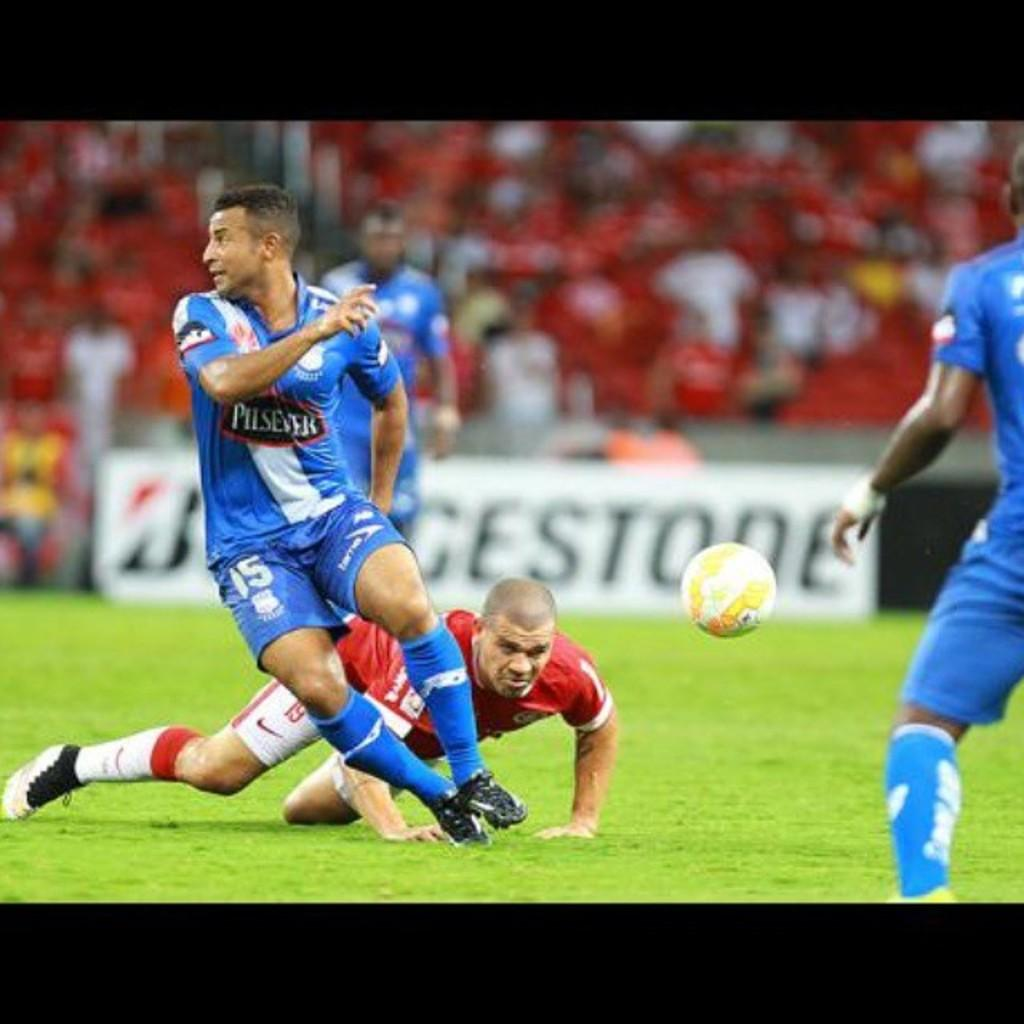<image>
Write a terse but informative summary of the picture. A soccer player wears a jersey that says Pilsener. 